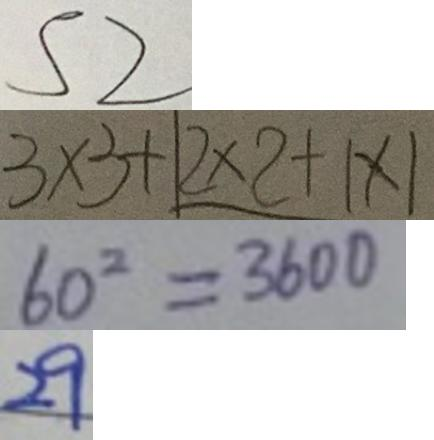Convert formula to latex. <formula><loc_0><loc_0><loc_500><loc_500>S 2 
 3 \times 3 + 1 2 \times 2 + 1 \times 1 
 6 0 ^ { 2 } = 3 6 0 0 
 2 9</formula> 